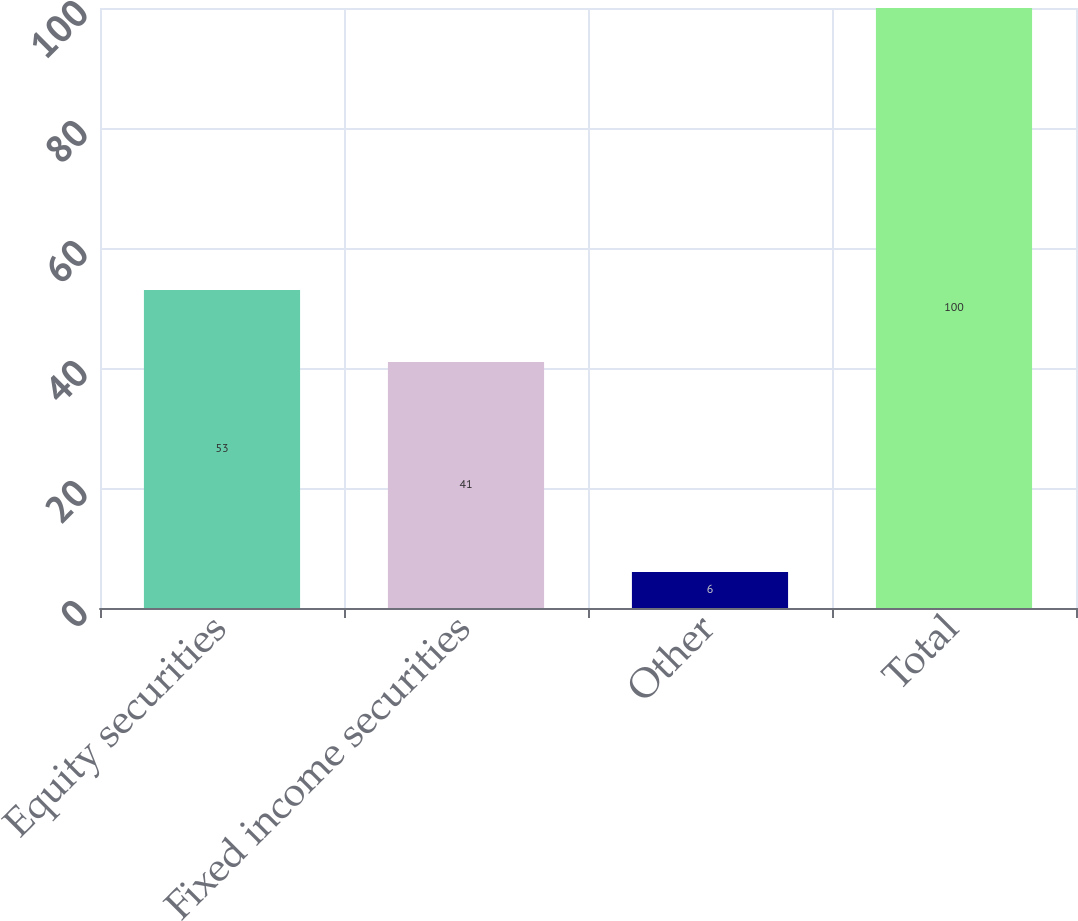Convert chart to OTSL. <chart><loc_0><loc_0><loc_500><loc_500><bar_chart><fcel>Equity securities<fcel>Fixed income securities<fcel>Other<fcel>Total<nl><fcel>53<fcel>41<fcel>6<fcel>100<nl></chart> 